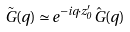Convert formula to latex. <formula><loc_0><loc_0><loc_500><loc_500>\tilde { G } ( q ) \simeq e ^ { - i q \cdot z ^ { \prime } _ { 0 } } \hat { G } ( q )</formula> 